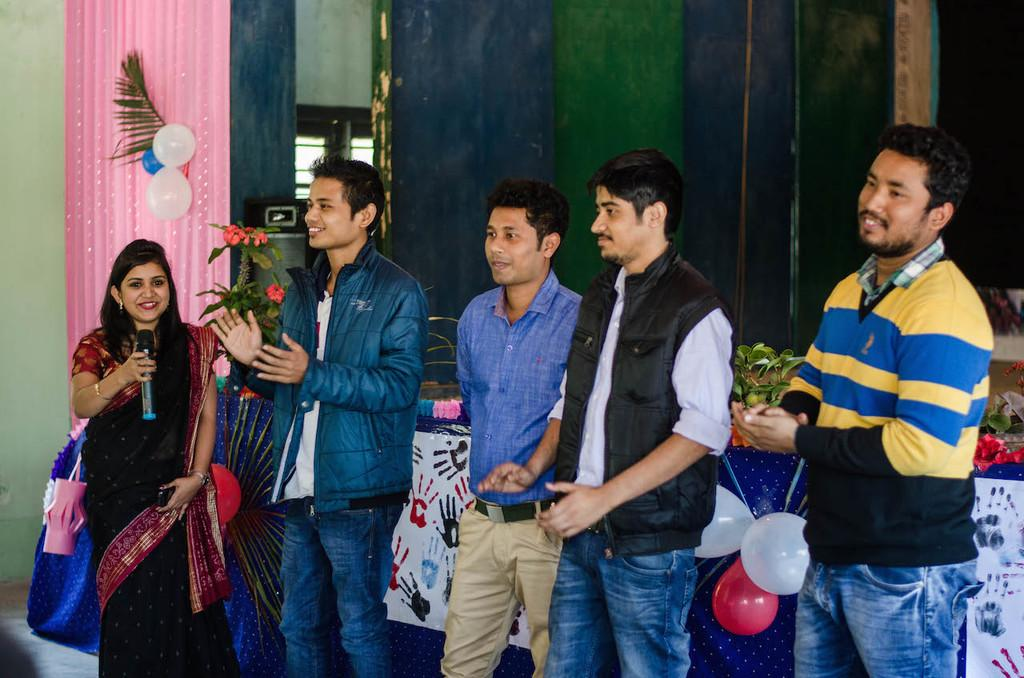How many people are present in the image? There are five persons standing in the image. What is the background of the image like? There is a wall in the image, and there is a door as well. What can be seen in the image that might be used for amplifying sound? There is a microphone (mike) in the image. What decorative elements are present in the image? There are balloons, flowers, plants, and other decorative items in the image. What type of meat is being served on a plate in the image? There is no plate or meat present in the image. How many people are walking in the image? The image does not show any people walking; there are five persons standing. 